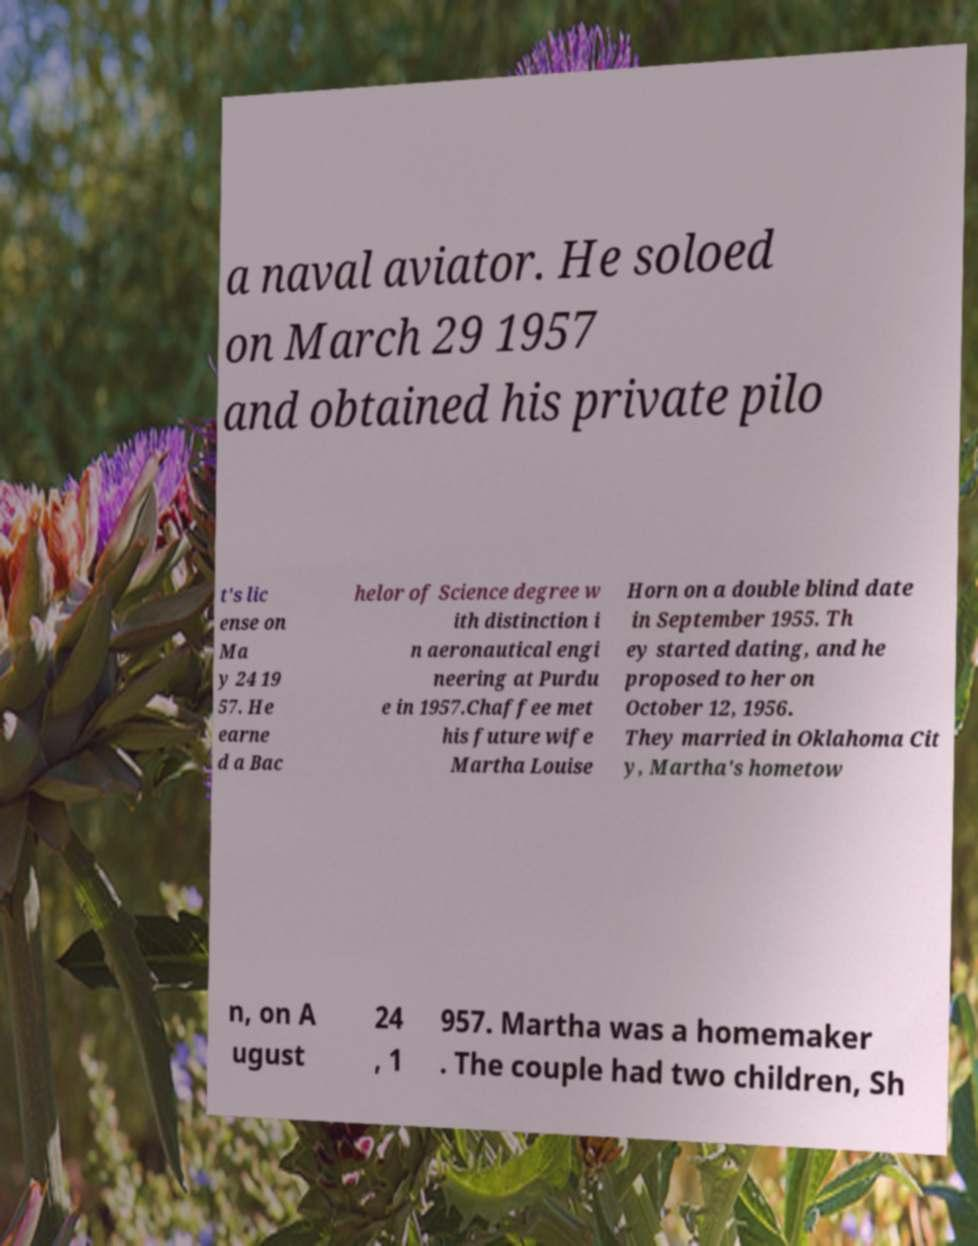Please identify and transcribe the text found in this image. a naval aviator. He soloed on March 29 1957 and obtained his private pilo t's lic ense on Ma y 24 19 57. He earne d a Bac helor of Science degree w ith distinction i n aeronautical engi neering at Purdu e in 1957.Chaffee met his future wife Martha Louise Horn on a double blind date in September 1955. Th ey started dating, and he proposed to her on October 12, 1956. They married in Oklahoma Cit y, Martha's hometow n, on A ugust 24 , 1 957. Martha was a homemaker . The couple had two children, Sh 